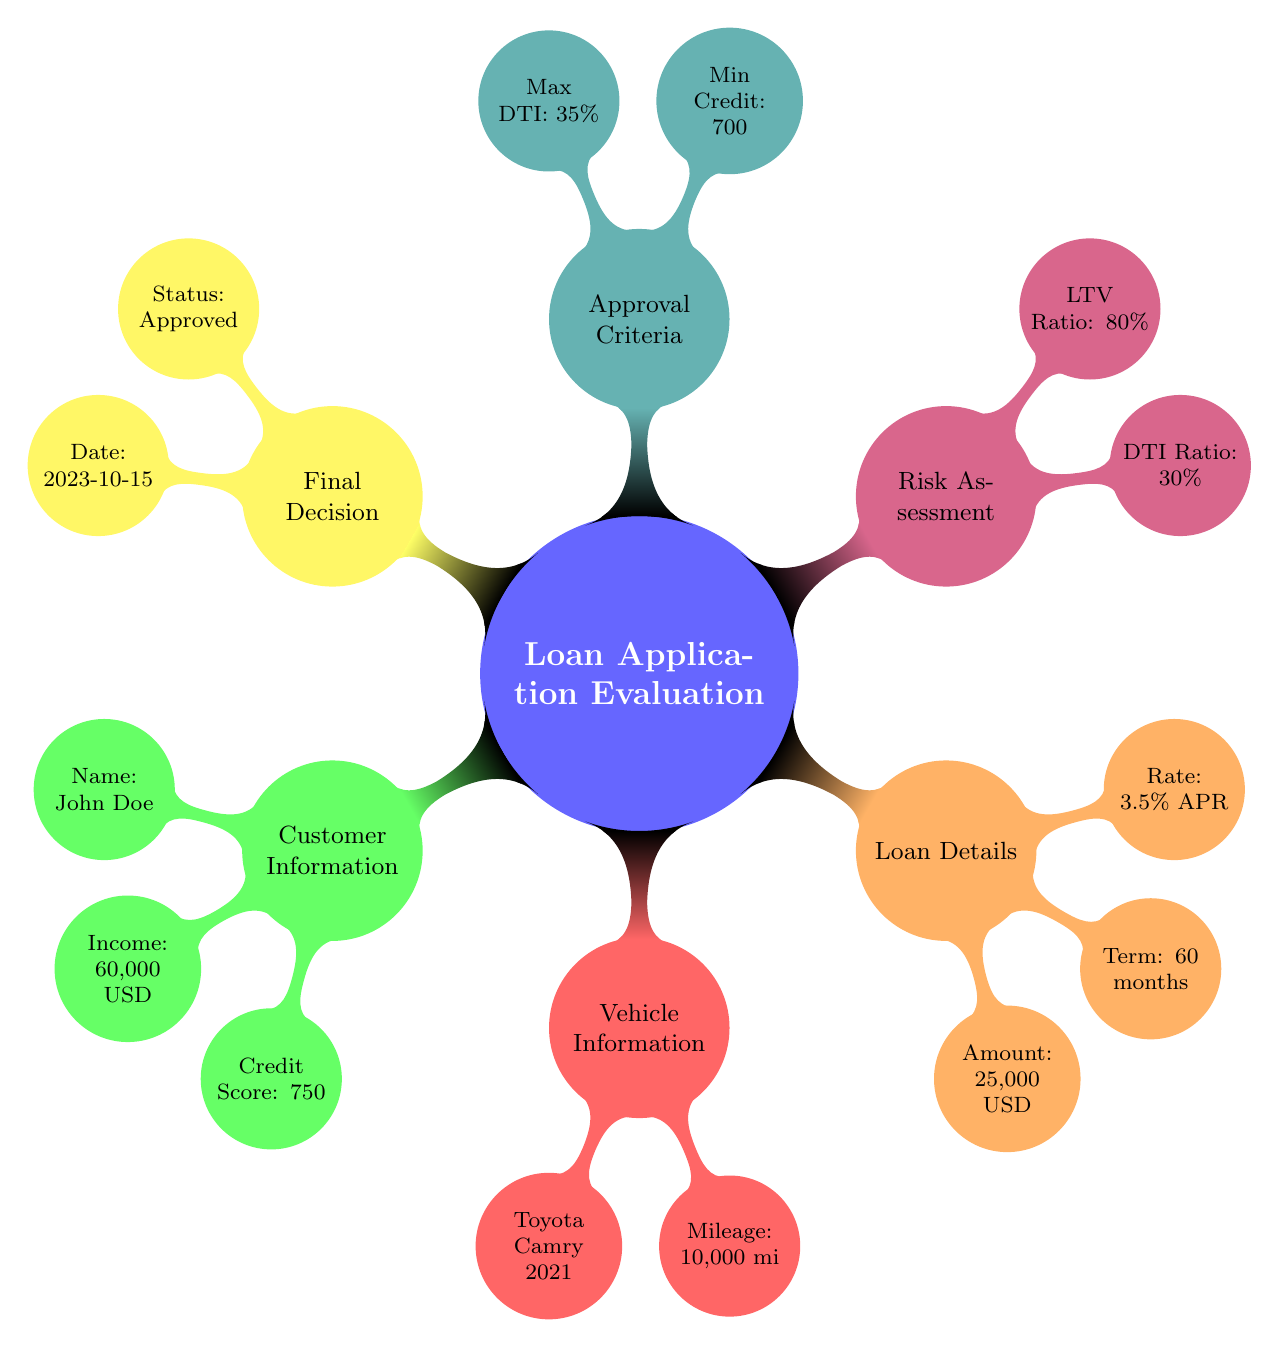What is the name of the customer? The diagram specifies that the customer's name is "John Doe" under the Customer Information node.
Answer: John Doe What is the credit score of the customer? The credit score is displayed as "750" in the Customer Information section of the diagram.
Answer: 750 What vehicle is the customer applying for? The Vehicle Information node mentions the vehicle as "Toyota Camry 2021."
Answer: Toyota Camry 2021 What is the loan amount requested by the customer? Under the Loan Details section, the amount is stated as "25,000 USD."
Answer: 25,000 USD What is the maximum allowed Debt-to-Income ratio according to the approval criteria? In the Approval Criteria node, the maximum Debt-to-Income ratio is noted as "35%."
Answer: 35% How many months is the loan term? The Loan Details section indicates a loan term of "60 months."
Answer: 60 months What special condition was mentioned in the final decision? The Final Decision node states a special condition is "Require proof of income."
Answer: Require proof of income Is the loan application approved? The Final Decision section clearly indicates the approval status as "Approved."
Answer: Approved What is the vehicle's mileage? The mileage of the vehicle is listed as "10,000 miles" in the Vehicle Information section.
Answer: 10,000 miles 